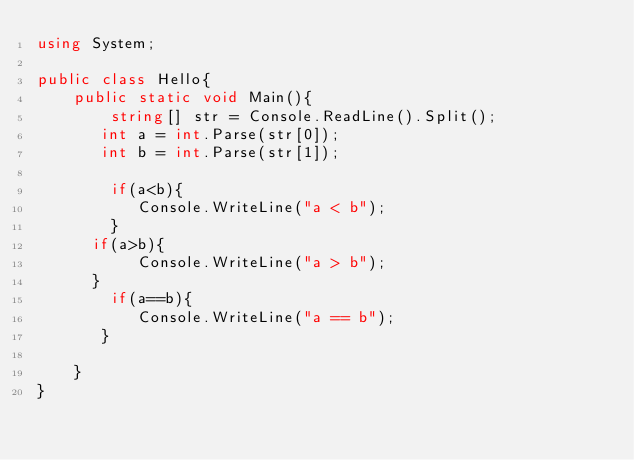Convert code to text. <code><loc_0><loc_0><loc_500><loc_500><_C#_>using System;

public class Hello{
    public static void Main(){
        string[] str = Console.ReadLine().Split();
       int a = int.Parse(str[0]);
       int b = int.Parse(str[1]);
       
        if(a<b){
           Console.WriteLine("a < b");
        }   
      if(a>b){
           Console.WriteLine("a > b");
      }
        if(a==b){
           Console.WriteLine("a == b");
       }
      
    }
}

</code> 